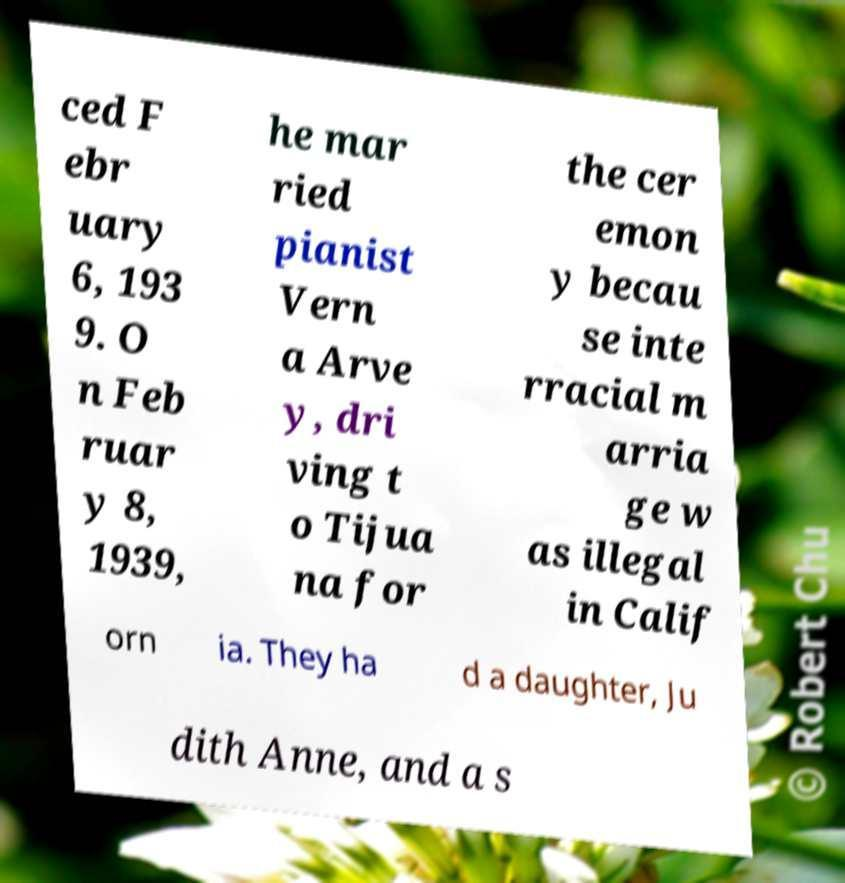What messages or text are displayed in this image? I need them in a readable, typed format. ced F ebr uary 6, 193 9. O n Feb ruar y 8, 1939, he mar ried pianist Vern a Arve y, dri ving t o Tijua na for the cer emon y becau se inte rracial m arria ge w as illegal in Calif orn ia. They ha d a daughter, Ju dith Anne, and a s 